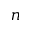<formula> <loc_0><loc_0><loc_500><loc_500>n</formula> 